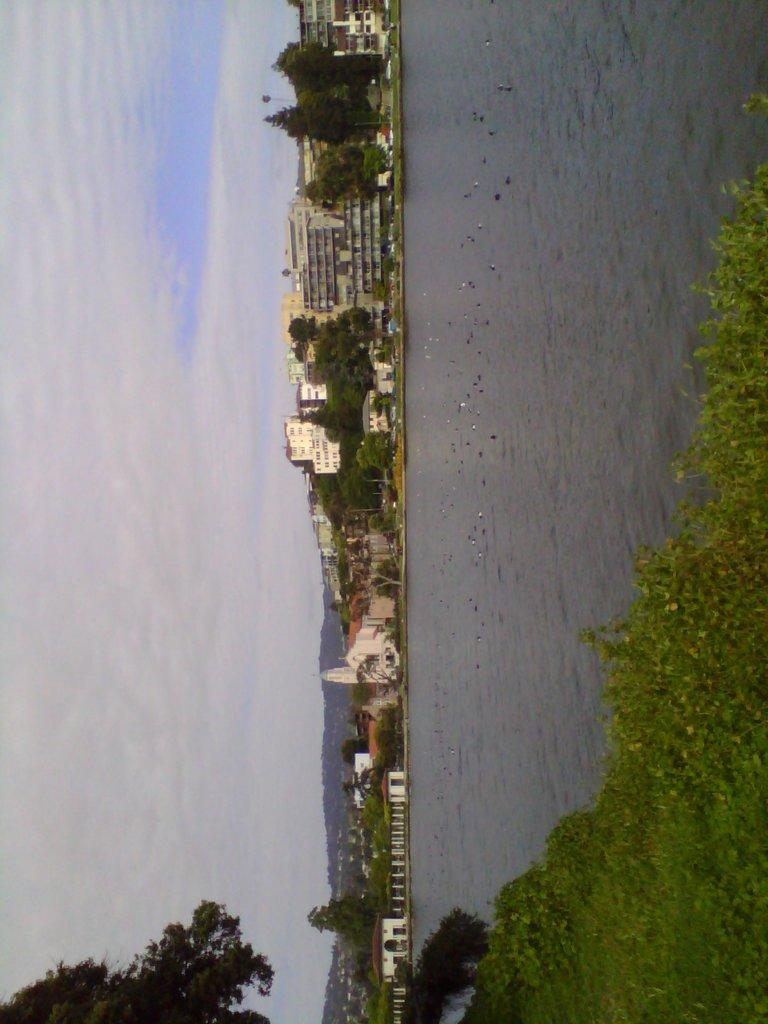What type of structures can be seen in the image? There are buildings with windows in the image. What natural elements are present in the image? There are trees, grass, and water visible in the image. What is flying in the image? There are birds flying in the image. What part of the natural environment is visible in the image? The sky is visible in the image. What type of advice can be seen written on the buildings in the image? There is no advice visible on the buildings in the image; they are simply structures with windows. What kind of glue is being used to hold the trees together in the image? There is no glue present in the image; the trees are naturally growing plants. 